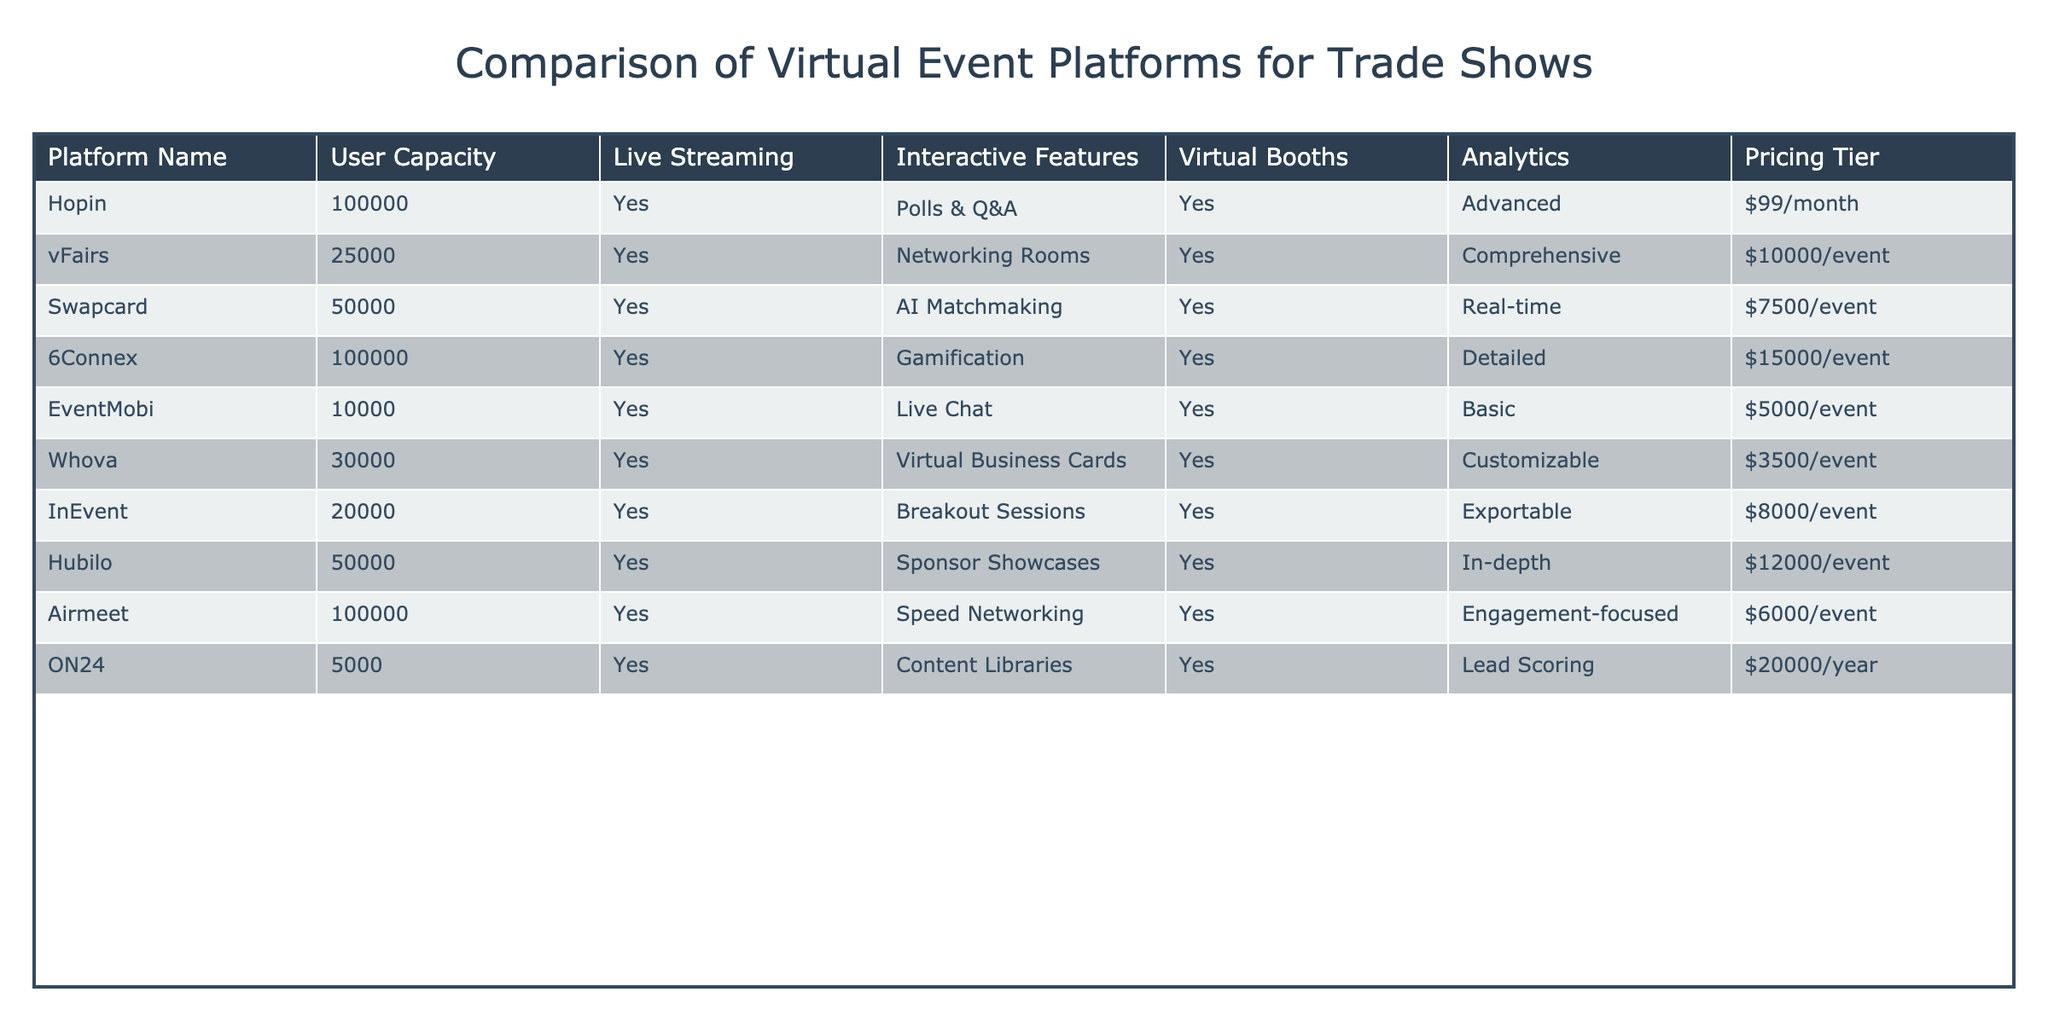What is the user capacity of the Hopin platform? The user capacity is directly listed in the row for the Hopin platform, which shows a user capacity of 100000.
Answer: 100000 Which platform has the lowest pricing tier? The pricing tier for each platform is listed, and the lowest is $3500 per event for Whova.
Answer: $3500/event Does the Airmeet platform offer interactive features? The table lists "Speed Networking" as an interactive feature for Airmeet, indicating that it does offer such features.
Answer: Yes What platforms provide analytics with their services? The analytics column can be checked for each platform, and the platforms that offer analytics are Hopin, vFairs, Swapcard, 6Connex, Airmeet, and Hubilo.
Answer: Hopin, vFairs, Swapcard, 6Connex, Airmeet, Hubilo What is the average user capacity of the platforms listed in the table? To calculate the average user capacity, we sum the user capacities of all platforms (100000 + 25000 + 50000 + 100000 + 10000 + 30000 + 20000 + 50000 + 100000 + 5000) = 400000. There are 10 platforms, so the average is 400000 / 10 = 40000.
Answer: 40000 Is vFairs the only platform that charges per event instead of per month? By looking at the pricing tier column, we see that vFairs, Swapcard, 6Connex, and others charge per event, thus indicating that vFairs is not the only one that charges this way.
Answer: No Which platform has the highest user capacity and offers analytics? The platforms with the highest user capacity are Hopin and 6Connex, both with 100000 users; however, only Hopin offers analytics, making it the correct answer.
Answer: Hopin What percentage of platforms offer live streaming? There are ten platforms listed, and all of them (10 out of 10) offer live streaming. The percentage is (10/10) * 100 = 100%.
Answer: 100% 